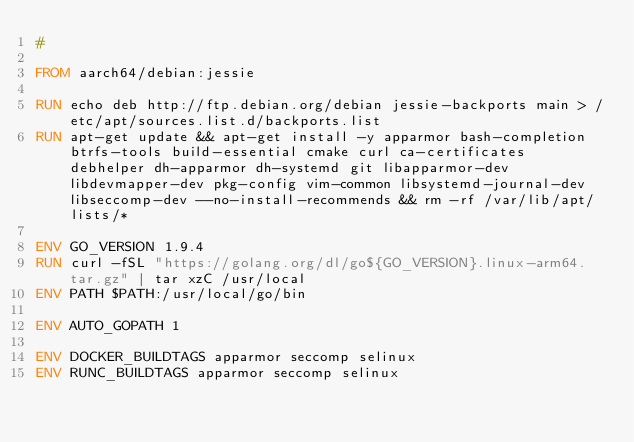<code> <loc_0><loc_0><loc_500><loc_500><_Dockerfile_>#

FROM aarch64/debian:jessie

RUN echo deb http://ftp.debian.org/debian jessie-backports main > /etc/apt/sources.list.d/backports.list
RUN apt-get update && apt-get install -y apparmor bash-completion btrfs-tools build-essential cmake curl ca-certificates debhelper dh-apparmor dh-systemd git libapparmor-dev libdevmapper-dev pkg-config vim-common libsystemd-journal-dev libseccomp-dev --no-install-recommends && rm -rf /var/lib/apt/lists/*

ENV GO_VERSION 1.9.4
RUN curl -fSL "https://golang.org/dl/go${GO_VERSION}.linux-arm64.tar.gz" | tar xzC /usr/local
ENV PATH $PATH:/usr/local/go/bin

ENV AUTO_GOPATH 1

ENV DOCKER_BUILDTAGS apparmor seccomp selinux
ENV RUNC_BUILDTAGS apparmor seccomp selinux
</code> 